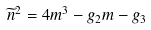<formula> <loc_0><loc_0><loc_500><loc_500>\widetilde { n } ^ { 2 } = 4 m ^ { 3 } - g _ { 2 } m - g _ { 3 }</formula> 